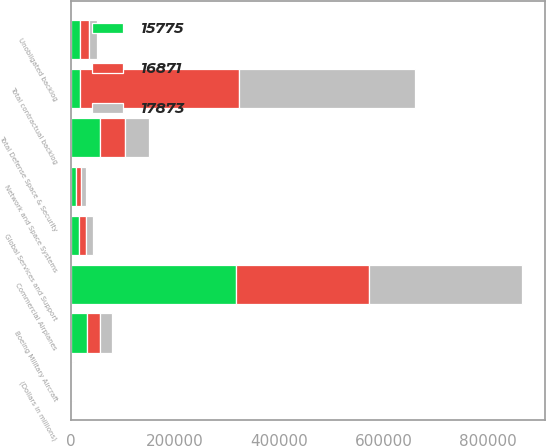Convert chart. <chart><loc_0><loc_0><loc_500><loc_500><stacked_bar_chart><ecel><fcel>(Dollars in millions)<fcel>Commercial Airplanes<fcel>Boeing Military Aircraft<fcel>Network and Space Systems<fcel>Global Services and Support<fcel>Total Defense Space & Security<fcel>Total contractual backlog<fcel>Unobligated backlog<nl><fcel>15775<fcel>2012<fcel>317287<fcel>29674<fcel>9692<fcel>15702<fcel>55068<fcel>17873<fcel>17873<nl><fcel>17873<fcel>2011<fcel>293303<fcel>24085<fcel>9024<fcel>13245<fcel>46354<fcel>339657<fcel>15775<nl><fcel>16871<fcel>2010<fcel>255591<fcel>25094<fcel>9567<fcel>13703<fcel>48364<fcel>303955<fcel>16871<nl></chart> 